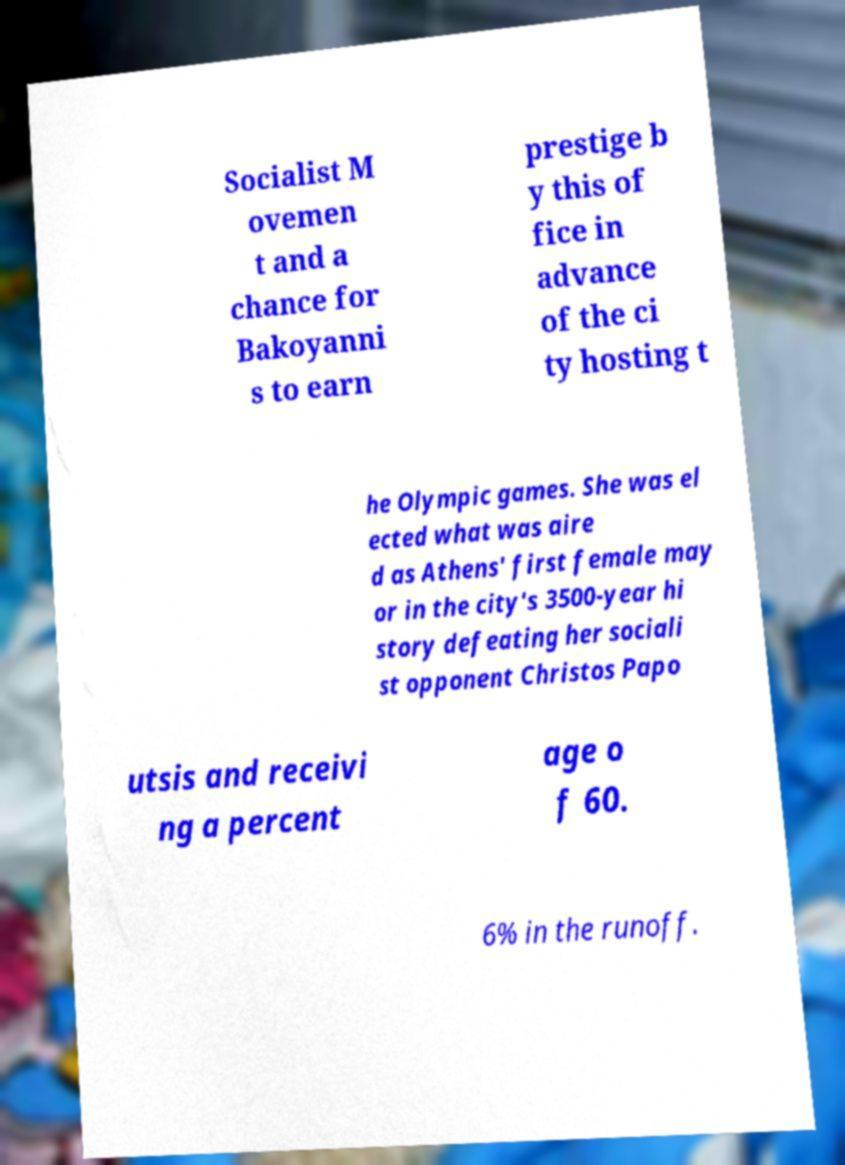Could you extract and type out the text from this image? Socialist M ovemen t and a chance for Bakoyanni s to earn prestige b y this of fice in advance of the ci ty hosting t he Olympic games. She was el ected what was aire d as Athens' first female may or in the city's 3500-year hi story defeating her sociali st opponent Christos Papo utsis and receivi ng a percent age o f 60. 6% in the runoff. 